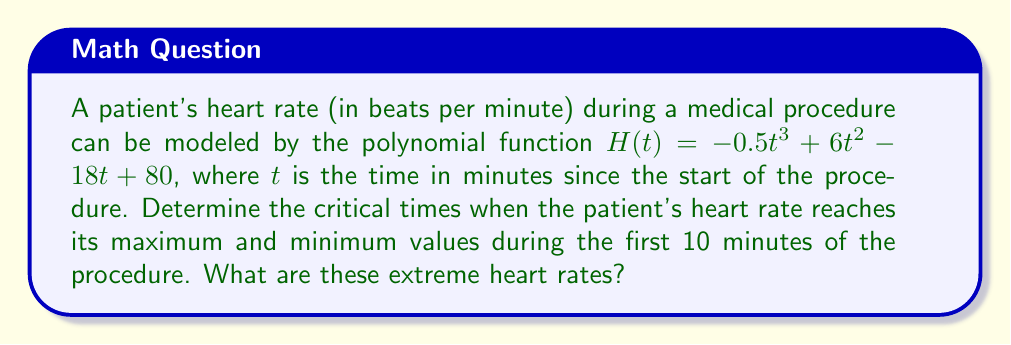Provide a solution to this math problem. To find the critical times and extreme heart rates, we need to analyze the turning points of the polynomial function. Here's how we can do this:

1) First, we need to find the derivative of $H(t)$:
   $H'(t) = -1.5t^2 + 12t - 18$

2) Set $H'(t) = 0$ to find the critical points:
   $-1.5t^2 + 12t - 18 = 0$

3) This is a quadratic equation. We can solve it using the quadratic formula:
   $t = \frac{-b \pm \sqrt{b^2 - 4ac}}{2a}$

   Where $a = -1.5$, $b = 12$, and $c = -18$

4) Plugging in these values:
   $t = \frac{-12 \pm \sqrt{12^2 - 4(-1.5)(-18)}}{2(-1.5)}$
   $= \frac{-12 \pm \sqrt{144 - 108}}{-3}$
   $= \frac{-12 \pm \sqrt{36}}{-3}$
   $= \frac{-12 \pm 6}{-3}$

5) This gives us two solutions:
   $t_1 = \frac{-12 + 6}{-3} = 2$ minutes
   $t_2 = \frac{-12 - 6}{-3} = 6$ minutes

6) To determine which point is the maximum and which is the minimum, we can check the second derivative:
   $H''(t) = -3t + 12$
   At $t = 2$: $H''(2) = -3(2) + 12 = 6 > 0$, so this is a minimum.
   At $t = 6$: $H''(6) = -3(6) + 12 = -6 < 0$, so this is a maximum.

7) Now, let's calculate the heart rates at these critical times:
   At $t = 2$: $H(2) = -0.5(2)^3 + 6(2)^2 - 18(2) + 80 = 72$ bpm
   At $t = 6$: $H(6) = -0.5(6)^3 + 6(6)^2 - 18(6) + 80 = 98$ bpm

Therefore, the patient's heart rate reaches its minimum of 72 bpm at 2 minutes into the procedure and its maximum of 98 bpm at 6 minutes into the procedure.
Answer: The critical times are 2 minutes (minimum) and 6 minutes (maximum). The extreme heart rates are 72 bpm (minimum) and 98 bpm (maximum). 